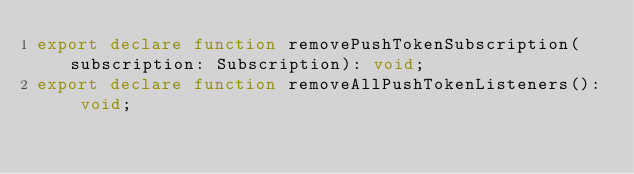<code> <loc_0><loc_0><loc_500><loc_500><_TypeScript_>export declare function removePushTokenSubscription(subscription: Subscription): void;
export declare function removeAllPushTokenListeners(): void;
</code> 